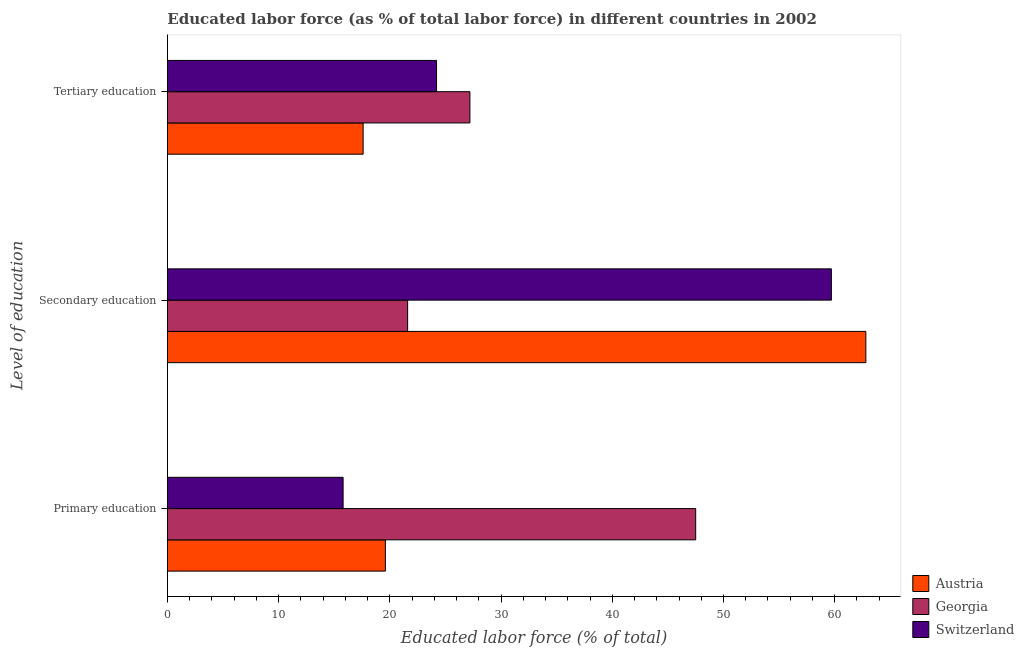How many different coloured bars are there?
Your answer should be compact. 3. Are the number of bars per tick equal to the number of legend labels?
Offer a very short reply. Yes. What is the label of the 2nd group of bars from the top?
Your answer should be compact. Secondary education. What is the percentage of labor force who received secondary education in Georgia?
Your answer should be very brief. 21.6. Across all countries, what is the maximum percentage of labor force who received primary education?
Your response must be concise. 47.5. Across all countries, what is the minimum percentage of labor force who received secondary education?
Make the answer very short. 21.6. In which country was the percentage of labor force who received primary education maximum?
Keep it short and to the point. Georgia. In which country was the percentage of labor force who received tertiary education minimum?
Give a very brief answer. Austria. What is the total percentage of labor force who received secondary education in the graph?
Give a very brief answer. 144.1. What is the difference between the percentage of labor force who received secondary education in Austria and that in Switzerland?
Provide a succinct answer. 3.1. What is the difference between the percentage of labor force who received primary education in Austria and the percentage of labor force who received secondary education in Switzerland?
Give a very brief answer. -40.1. What is the average percentage of labor force who received secondary education per country?
Your response must be concise. 48.03. What is the difference between the percentage of labor force who received tertiary education and percentage of labor force who received secondary education in Austria?
Make the answer very short. -45.2. What is the ratio of the percentage of labor force who received secondary education in Georgia to that in Switzerland?
Your answer should be compact. 0.36. Is the percentage of labor force who received tertiary education in Georgia less than that in Switzerland?
Provide a succinct answer. No. What is the difference between the highest and the second highest percentage of labor force who received tertiary education?
Offer a terse response. 3. What is the difference between the highest and the lowest percentage of labor force who received secondary education?
Ensure brevity in your answer.  41.2. In how many countries, is the percentage of labor force who received tertiary education greater than the average percentage of labor force who received tertiary education taken over all countries?
Your answer should be compact. 2. Is the sum of the percentage of labor force who received secondary education in Austria and Georgia greater than the maximum percentage of labor force who received tertiary education across all countries?
Your response must be concise. Yes. What does the 1st bar from the top in Primary education represents?
Offer a terse response. Switzerland. Is it the case that in every country, the sum of the percentage of labor force who received primary education and percentage of labor force who received secondary education is greater than the percentage of labor force who received tertiary education?
Keep it short and to the point. Yes. Are the values on the major ticks of X-axis written in scientific E-notation?
Your response must be concise. No. Does the graph contain any zero values?
Your answer should be compact. No. Where does the legend appear in the graph?
Your answer should be compact. Bottom right. How many legend labels are there?
Give a very brief answer. 3. What is the title of the graph?
Your answer should be very brief. Educated labor force (as % of total labor force) in different countries in 2002. What is the label or title of the X-axis?
Ensure brevity in your answer.  Educated labor force (% of total). What is the label or title of the Y-axis?
Keep it short and to the point. Level of education. What is the Educated labor force (% of total) in Austria in Primary education?
Make the answer very short. 19.6. What is the Educated labor force (% of total) of Georgia in Primary education?
Make the answer very short. 47.5. What is the Educated labor force (% of total) in Switzerland in Primary education?
Your answer should be compact. 15.8. What is the Educated labor force (% of total) in Austria in Secondary education?
Your response must be concise. 62.8. What is the Educated labor force (% of total) of Georgia in Secondary education?
Make the answer very short. 21.6. What is the Educated labor force (% of total) of Switzerland in Secondary education?
Your answer should be compact. 59.7. What is the Educated labor force (% of total) of Austria in Tertiary education?
Provide a succinct answer. 17.6. What is the Educated labor force (% of total) of Georgia in Tertiary education?
Your answer should be compact. 27.2. What is the Educated labor force (% of total) of Switzerland in Tertiary education?
Provide a short and direct response. 24.2. Across all Level of education, what is the maximum Educated labor force (% of total) of Austria?
Make the answer very short. 62.8. Across all Level of education, what is the maximum Educated labor force (% of total) in Georgia?
Ensure brevity in your answer.  47.5. Across all Level of education, what is the maximum Educated labor force (% of total) in Switzerland?
Give a very brief answer. 59.7. Across all Level of education, what is the minimum Educated labor force (% of total) in Austria?
Offer a terse response. 17.6. Across all Level of education, what is the minimum Educated labor force (% of total) in Georgia?
Your answer should be very brief. 21.6. Across all Level of education, what is the minimum Educated labor force (% of total) in Switzerland?
Make the answer very short. 15.8. What is the total Educated labor force (% of total) in Georgia in the graph?
Offer a terse response. 96.3. What is the total Educated labor force (% of total) of Switzerland in the graph?
Your answer should be compact. 99.7. What is the difference between the Educated labor force (% of total) in Austria in Primary education and that in Secondary education?
Give a very brief answer. -43.2. What is the difference between the Educated labor force (% of total) in Georgia in Primary education and that in Secondary education?
Your answer should be very brief. 25.9. What is the difference between the Educated labor force (% of total) of Switzerland in Primary education and that in Secondary education?
Provide a succinct answer. -43.9. What is the difference between the Educated labor force (% of total) in Georgia in Primary education and that in Tertiary education?
Give a very brief answer. 20.3. What is the difference between the Educated labor force (% of total) of Austria in Secondary education and that in Tertiary education?
Your answer should be very brief. 45.2. What is the difference between the Educated labor force (% of total) of Georgia in Secondary education and that in Tertiary education?
Your answer should be very brief. -5.6. What is the difference between the Educated labor force (% of total) in Switzerland in Secondary education and that in Tertiary education?
Provide a succinct answer. 35.5. What is the difference between the Educated labor force (% of total) in Austria in Primary education and the Educated labor force (% of total) in Georgia in Secondary education?
Your response must be concise. -2. What is the difference between the Educated labor force (% of total) of Austria in Primary education and the Educated labor force (% of total) of Switzerland in Secondary education?
Offer a terse response. -40.1. What is the difference between the Educated labor force (% of total) in Austria in Primary education and the Educated labor force (% of total) in Georgia in Tertiary education?
Provide a short and direct response. -7.6. What is the difference between the Educated labor force (% of total) in Georgia in Primary education and the Educated labor force (% of total) in Switzerland in Tertiary education?
Give a very brief answer. 23.3. What is the difference between the Educated labor force (% of total) in Austria in Secondary education and the Educated labor force (% of total) in Georgia in Tertiary education?
Give a very brief answer. 35.6. What is the difference between the Educated labor force (% of total) in Austria in Secondary education and the Educated labor force (% of total) in Switzerland in Tertiary education?
Offer a very short reply. 38.6. What is the difference between the Educated labor force (% of total) of Georgia in Secondary education and the Educated labor force (% of total) of Switzerland in Tertiary education?
Provide a short and direct response. -2.6. What is the average Educated labor force (% of total) of Austria per Level of education?
Keep it short and to the point. 33.33. What is the average Educated labor force (% of total) in Georgia per Level of education?
Your response must be concise. 32.1. What is the average Educated labor force (% of total) in Switzerland per Level of education?
Make the answer very short. 33.23. What is the difference between the Educated labor force (% of total) of Austria and Educated labor force (% of total) of Georgia in Primary education?
Give a very brief answer. -27.9. What is the difference between the Educated labor force (% of total) in Austria and Educated labor force (% of total) in Switzerland in Primary education?
Give a very brief answer. 3.8. What is the difference between the Educated labor force (% of total) of Georgia and Educated labor force (% of total) of Switzerland in Primary education?
Make the answer very short. 31.7. What is the difference between the Educated labor force (% of total) in Austria and Educated labor force (% of total) in Georgia in Secondary education?
Your answer should be very brief. 41.2. What is the difference between the Educated labor force (% of total) of Georgia and Educated labor force (% of total) of Switzerland in Secondary education?
Your answer should be compact. -38.1. What is the difference between the Educated labor force (% of total) in Austria and Educated labor force (% of total) in Georgia in Tertiary education?
Make the answer very short. -9.6. What is the difference between the Educated labor force (% of total) in Austria and Educated labor force (% of total) in Switzerland in Tertiary education?
Keep it short and to the point. -6.6. What is the difference between the Educated labor force (% of total) of Georgia and Educated labor force (% of total) of Switzerland in Tertiary education?
Keep it short and to the point. 3. What is the ratio of the Educated labor force (% of total) of Austria in Primary education to that in Secondary education?
Make the answer very short. 0.31. What is the ratio of the Educated labor force (% of total) in Georgia in Primary education to that in Secondary education?
Offer a very short reply. 2.2. What is the ratio of the Educated labor force (% of total) of Switzerland in Primary education to that in Secondary education?
Offer a very short reply. 0.26. What is the ratio of the Educated labor force (% of total) in Austria in Primary education to that in Tertiary education?
Your response must be concise. 1.11. What is the ratio of the Educated labor force (% of total) of Georgia in Primary education to that in Tertiary education?
Give a very brief answer. 1.75. What is the ratio of the Educated labor force (% of total) in Switzerland in Primary education to that in Tertiary education?
Your answer should be compact. 0.65. What is the ratio of the Educated labor force (% of total) of Austria in Secondary education to that in Tertiary education?
Provide a short and direct response. 3.57. What is the ratio of the Educated labor force (% of total) of Georgia in Secondary education to that in Tertiary education?
Keep it short and to the point. 0.79. What is the ratio of the Educated labor force (% of total) in Switzerland in Secondary education to that in Tertiary education?
Keep it short and to the point. 2.47. What is the difference between the highest and the second highest Educated labor force (% of total) in Austria?
Offer a terse response. 43.2. What is the difference between the highest and the second highest Educated labor force (% of total) of Georgia?
Provide a short and direct response. 20.3. What is the difference between the highest and the second highest Educated labor force (% of total) of Switzerland?
Ensure brevity in your answer.  35.5. What is the difference between the highest and the lowest Educated labor force (% of total) in Austria?
Your answer should be very brief. 45.2. What is the difference between the highest and the lowest Educated labor force (% of total) in Georgia?
Make the answer very short. 25.9. What is the difference between the highest and the lowest Educated labor force (% of total) of Switzerland?
Your response must be concise. 43.9. 